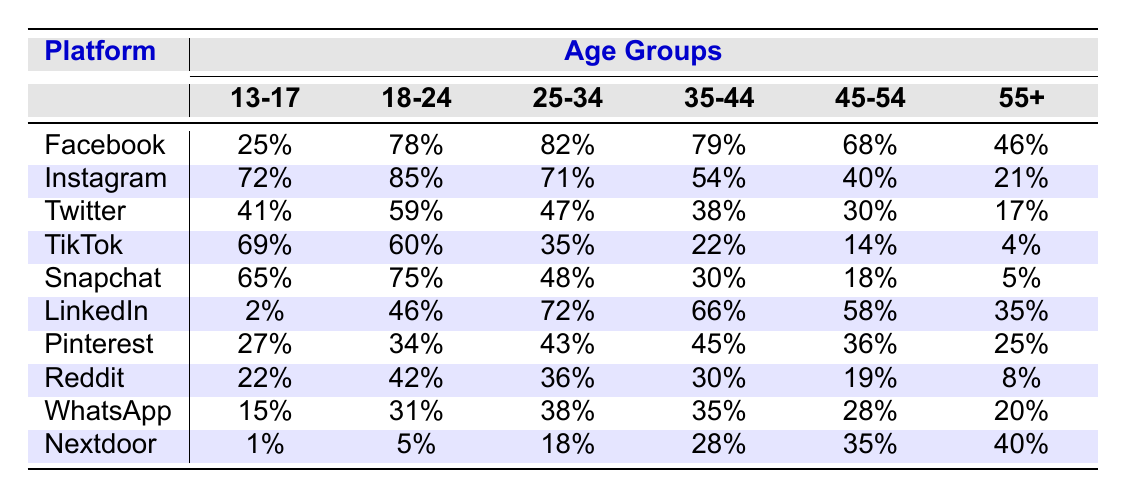What's the percentage of users aged 18-24 on Facebook? The table shows that 78% of users aged 18-24 use Facebook.
Answer: 78% Which social media platform has the lowest usage rate among users aged 55 and above? In the table, the platform with the lowest usage rate for users aged 55+ is TikTok, with only 4%.
Answer: TikTok What is the difference in the percentage of Instagram users between the 13-17 age group and the 45-54 age group? For the 13-17 age group, 72% use Instagram, and for 45-54, it is 40%. The difference is 72% - 40% = 32%.
Answer: 32% Which social media platform shows a significant drop in usage from the 18-24 age group to the 35-44 age group? Upon comparing the percentages, TikTok drops from 60% in the 18-24 age group to 22% in the 35-44 age group, showing a significant drop of 38%.
Answer: TikTok Is the usage of LinkedIn higher than that of Pinterest for the age group 25-34? In the table, LinkedIn usage for the 25-34 age group is 72%, while Pinterest is 43%. Therefore, LinkedIn usage is indeed higher than Pinterest.
Answer: Yes What is the average percentage of Snapchat usage across all age groups? To find the average, add the percentages for Snapchat (65% + 75% + 48% + 30% + 18% + 5% = 241%) and divide by the number of age groups (6), leading to an average of 241%/6 ≈ 40.17%.
Answer: 40.17% How does the percentage of WhatsApp users aged 45-54 compare to users aged 35-44? The percentage for 45-54 is 28%, and for 35-44 it is 35%. Since 35% is greater than 28%, WhatsApp usage is lower in the 45-54 age group.
Answer: Lower For which age group is TikTok usage the highest? The table shows that TikTok usage is highest among the 13-17 age group, where it is 69%.
Answer: 13-17 What social media platform has the closest user percentage between the 35-44 and 45-54 age groups? Comparing the platforms, Nextdoor has 28% for the 35-44 group and 35% for the 45-54 group. The difference is 7%, which is the smallest difference among all platforms.
Answer: Nextdoor Is Instagram the preferred platform for users aged 18-24 compared to other platforms in the same age group? Instagram has the highest usage at 85% among users aged 18-24, followed by Facebook at 78%, which confirms it as the preferred platform.
Answer: Yes 